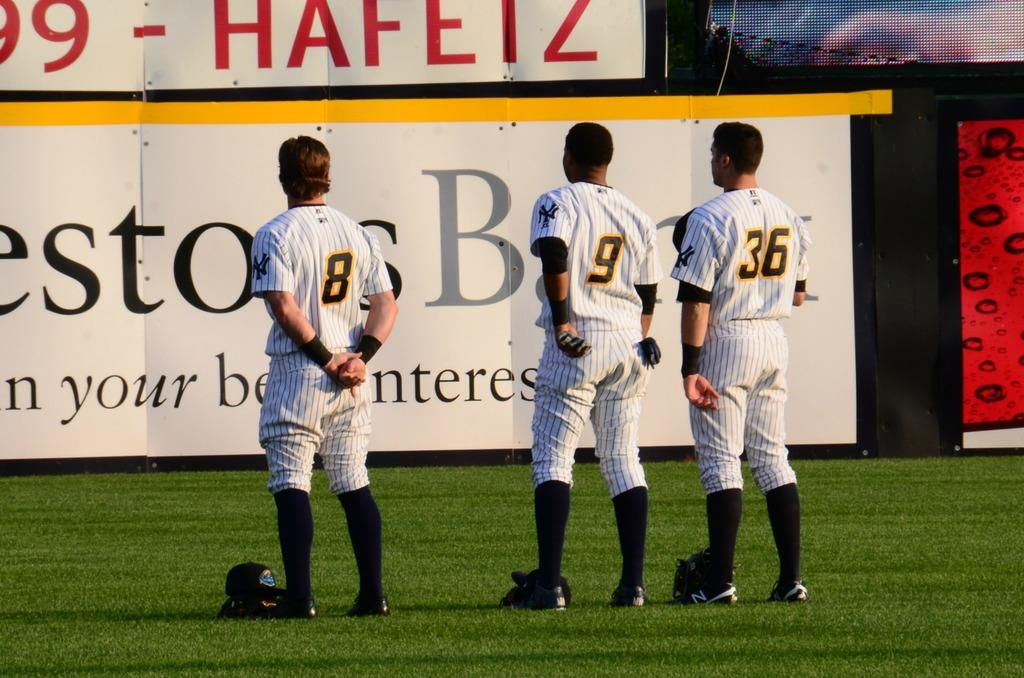<image>
Give a short and clear explanation of the subsequent image. Three baseball players are standing on the field looking at a sign that says Hafetz. 